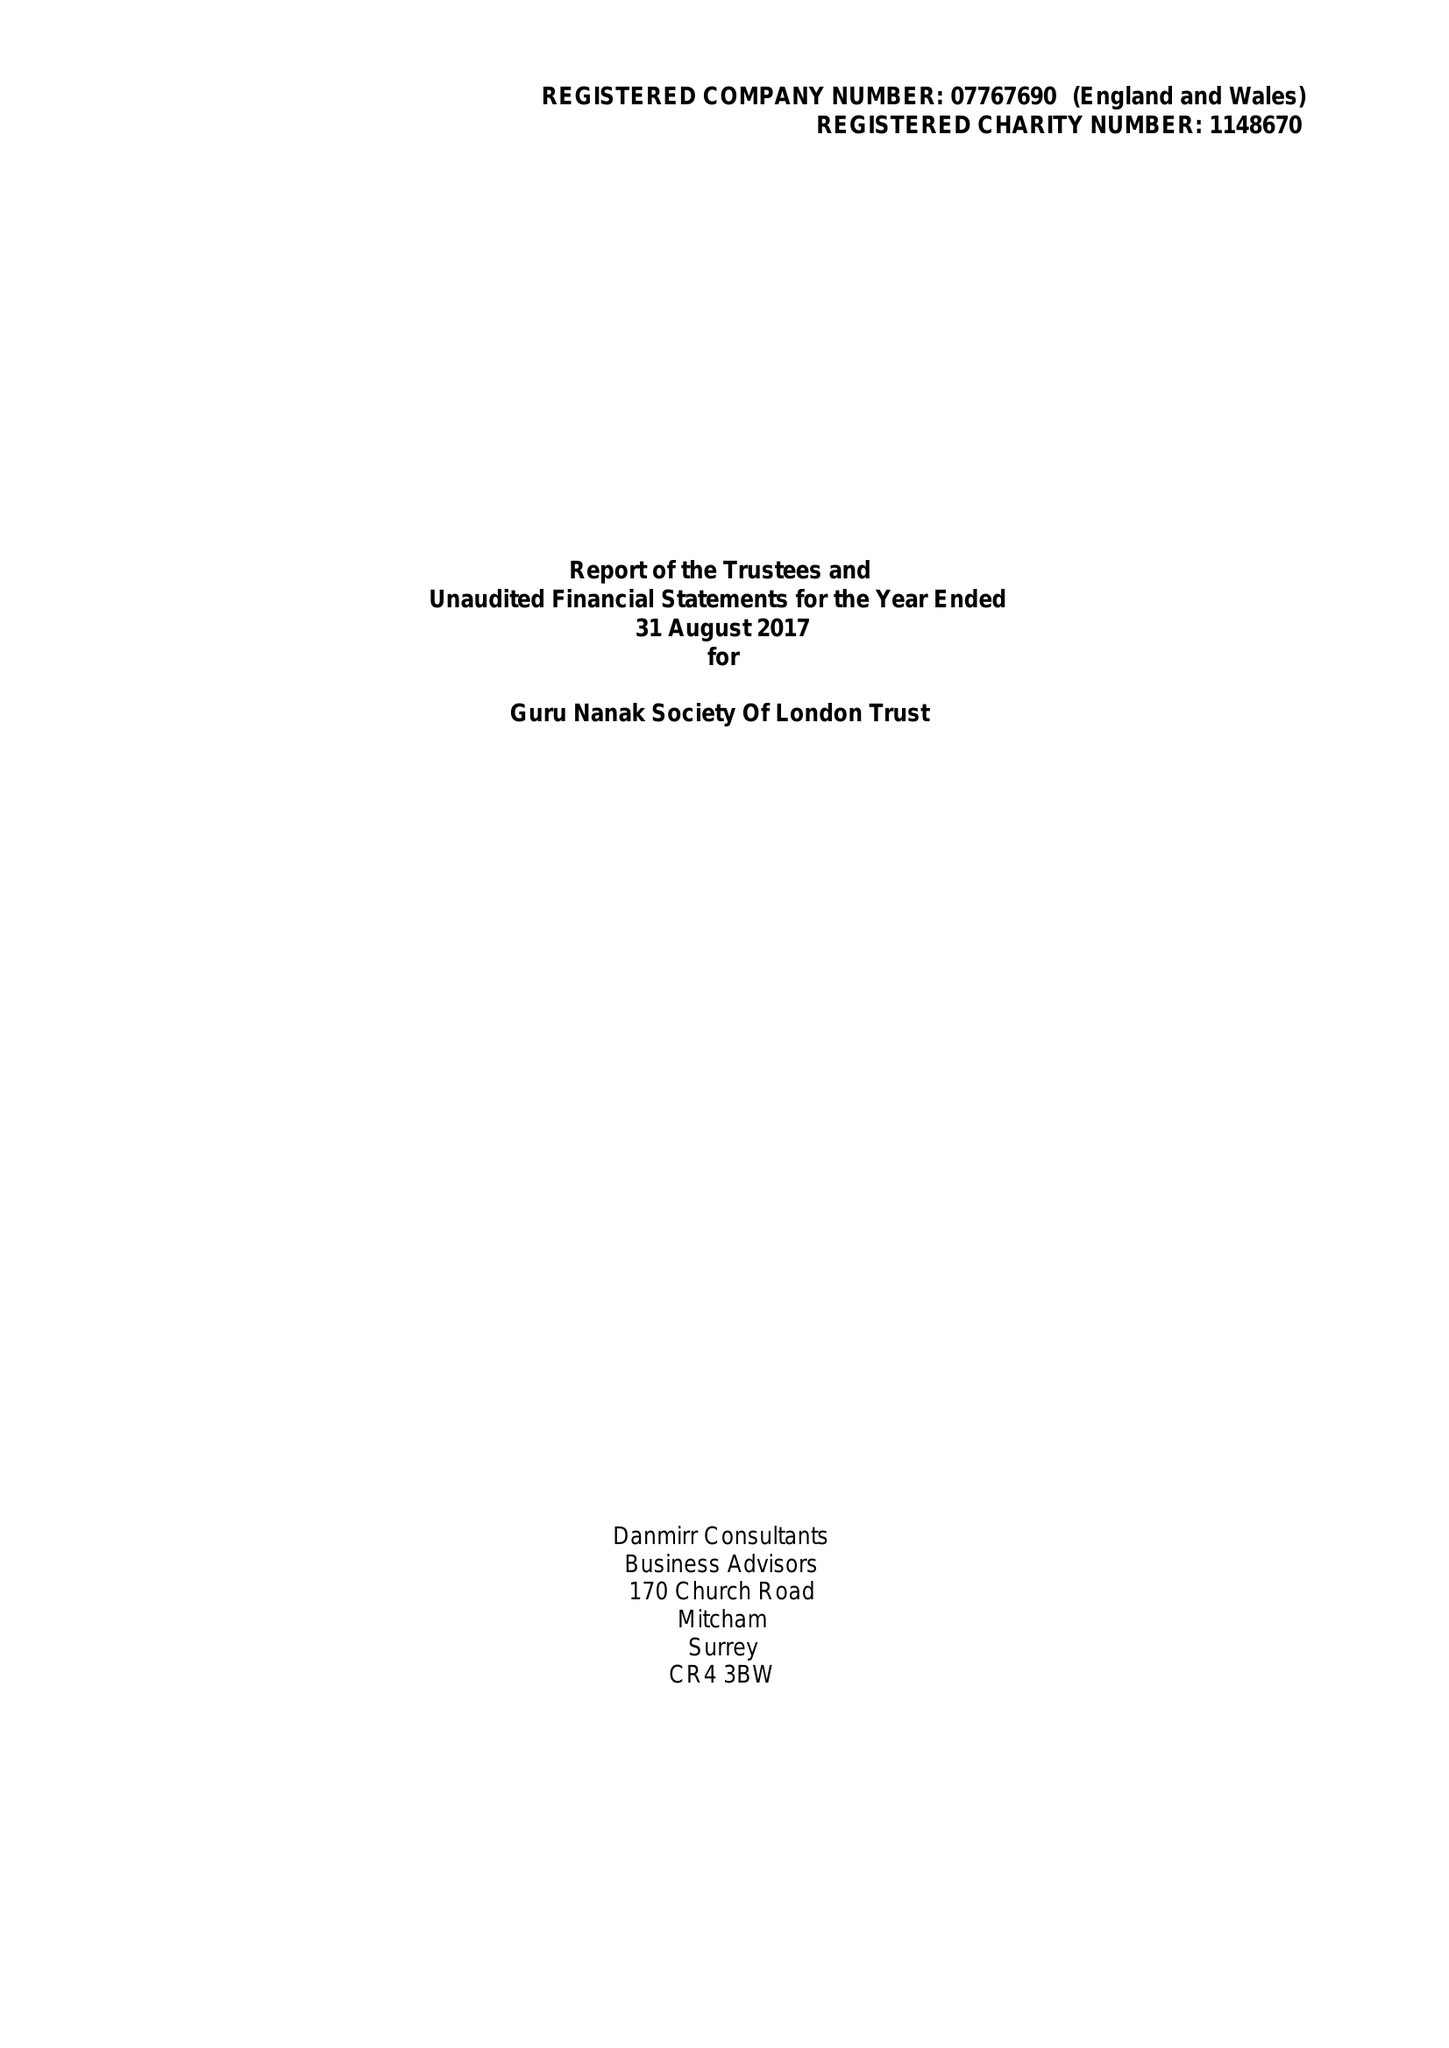What is the value for the report_date?
Answer the question using a single word or phrase. 2017-08-31 